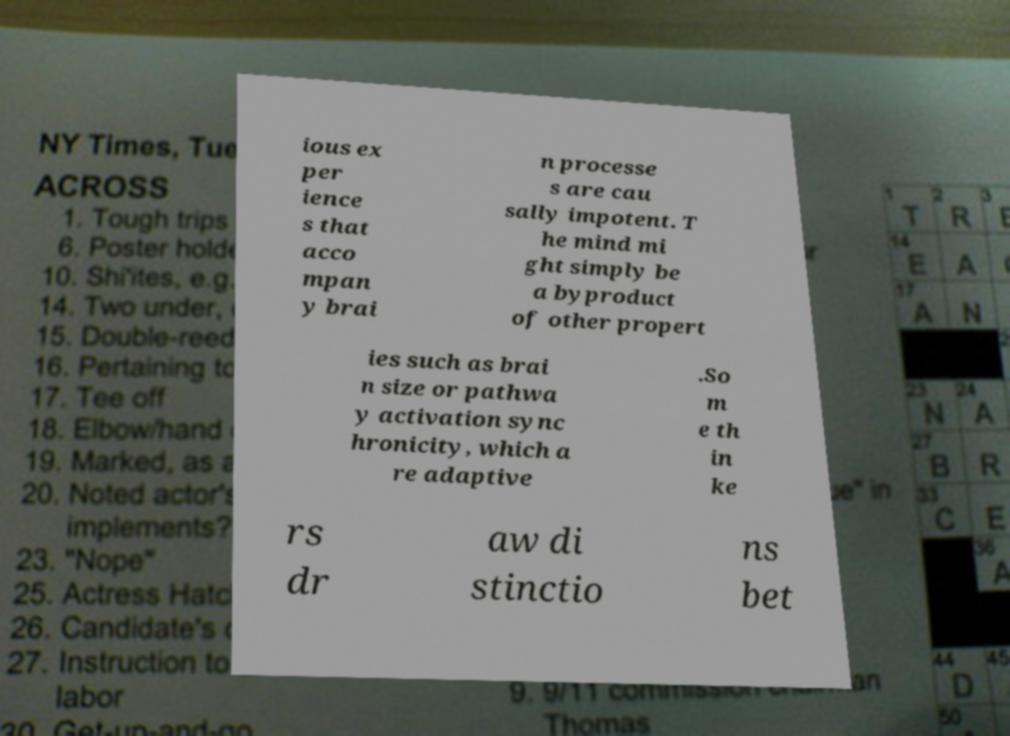Can you read and provide the text displayed in the image?This photo seems to have some interesting text. Can you extract and type it out for me? ious ex per ience s that acco mpan y brai n processe s are cau sally impotent. T he mind mi ght simply be a byproduct of other propert ies such as brai n size or pathwa y activation sync hronicity, which a re adaptive .So m e th in ke rs dr aw di stinctio ns bet 